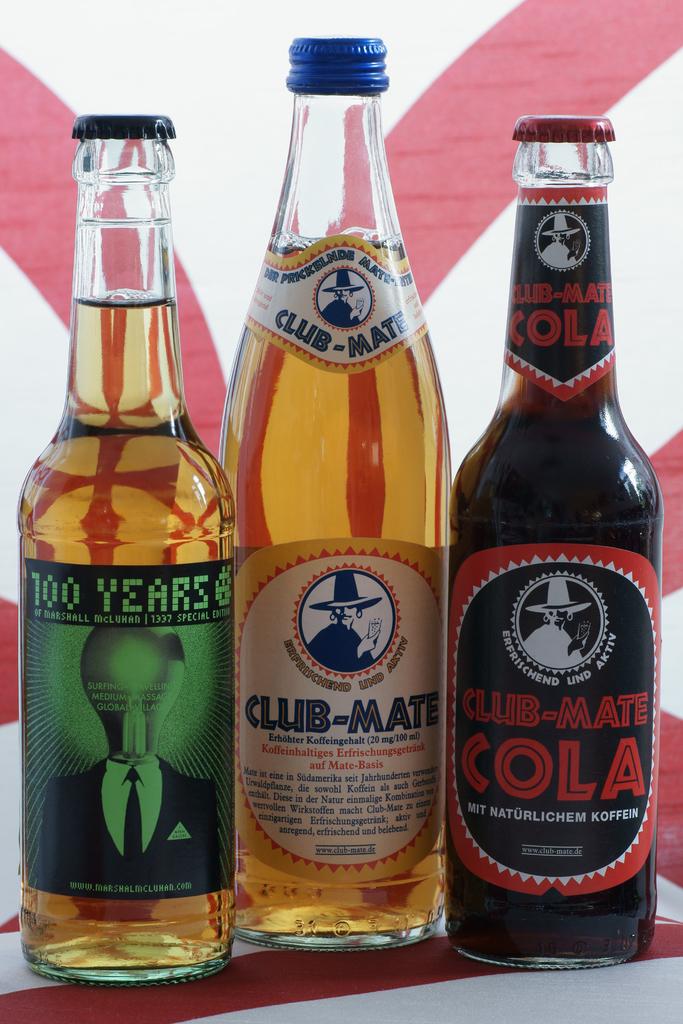Nutrition food product?
Your response must be concise. No. 